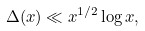<formula> <loc_0><loc_0><loc_500><loc_500>\Delta ( x ) \ll x ^ { 1 / 2 } \log x ,</formula> 